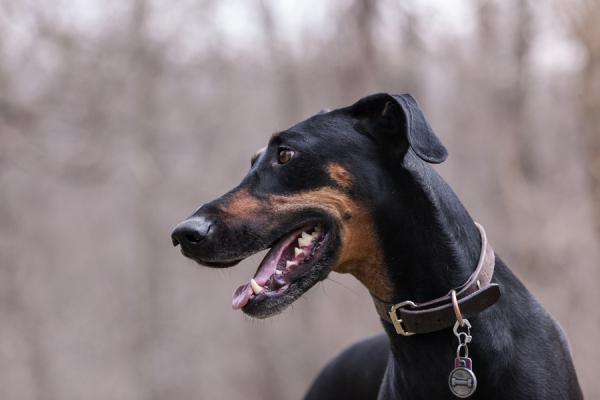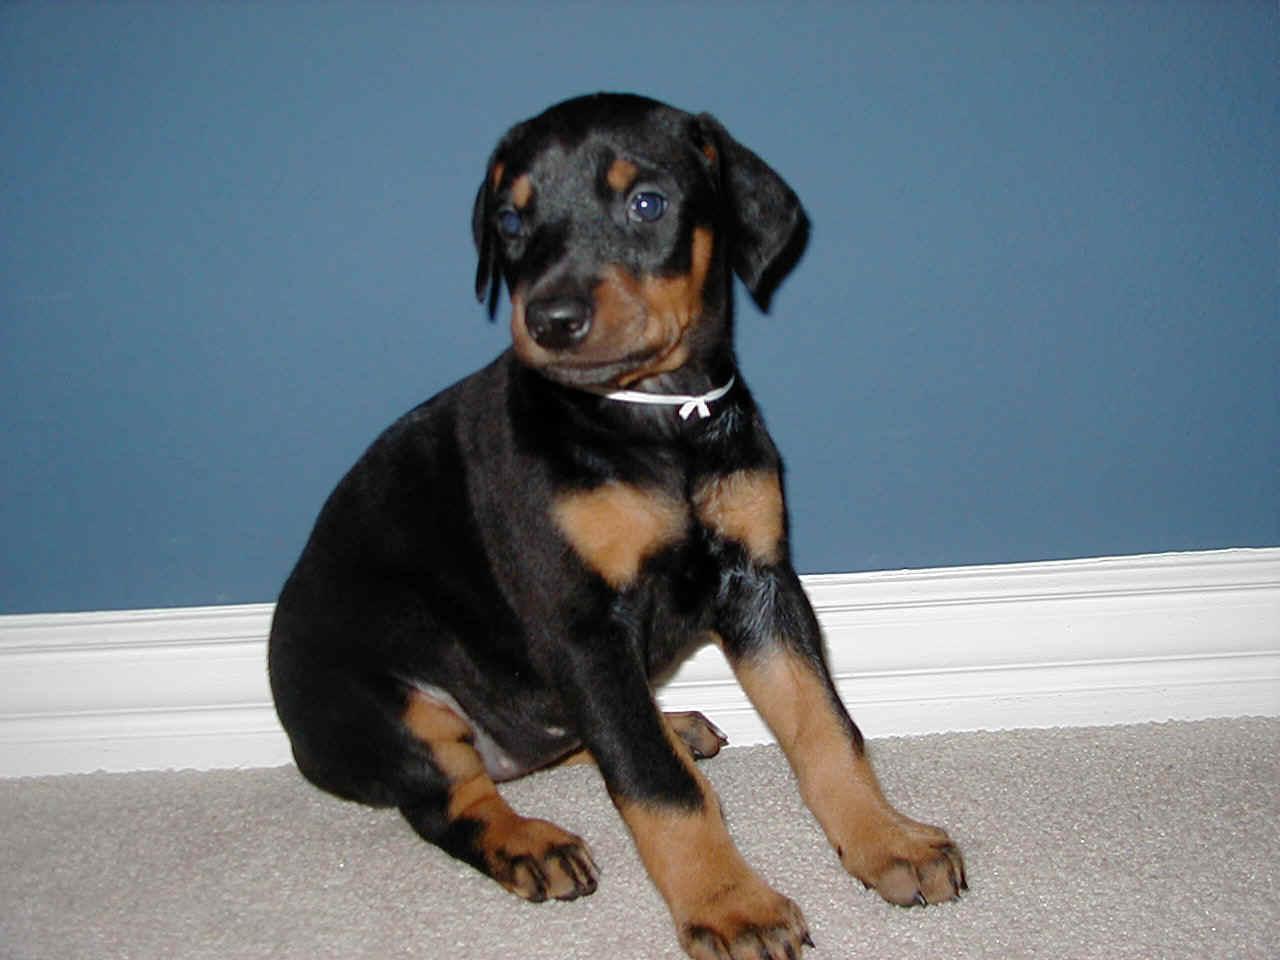The first image is the image on the left, the second image is the image on the right. For the images shown, is this caption "In at least one image there is a black and brown dog leaning right with its head tilted forward right." true? Answer yes or no. No. The first image is the image on the left, the second image is the image on the right. For the images shown, is this caption "A dog is sitting on carpet." true? Answer yes or no. Yes. 